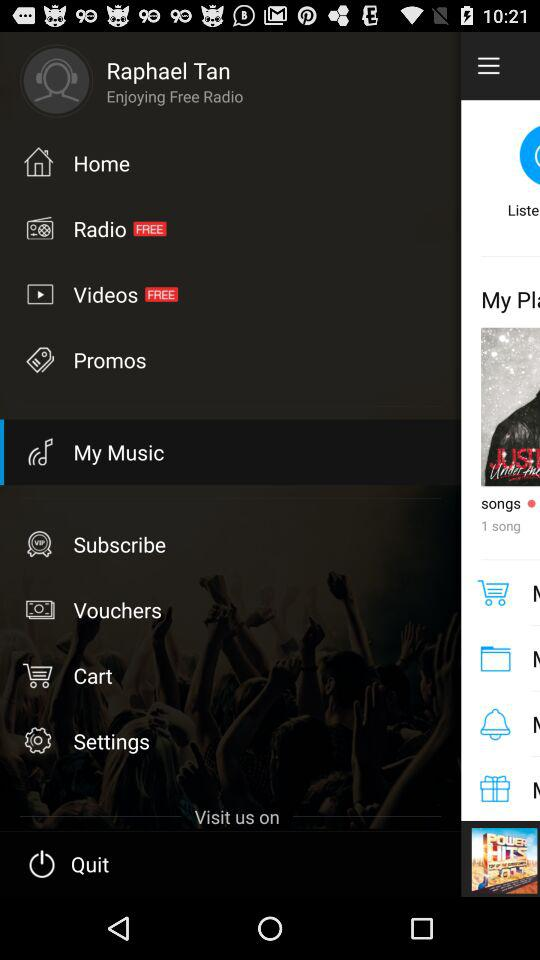What's the user profile name? The user profile name is Raphael Tan. 